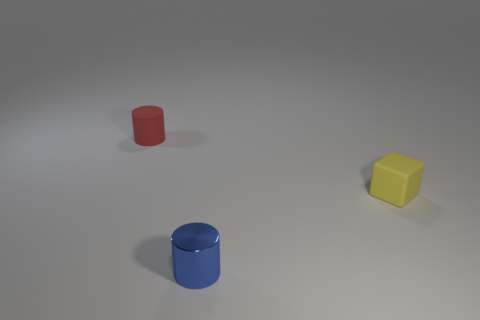Add 3 tiny purple metal objects. How many objects exist? 6 Subtract all blocks. How many objects are left? 2 Subtract 1 yellow cubes. How many objects are left? 2 Subtract all tiny blue cylinders. Subtract all tiny matte things. How many objects are left? 0 Add 2 tiny red rubber things. How many tiny red rubber things are left? 3 Add 3 tiny things. How many tiny things exist? 6 